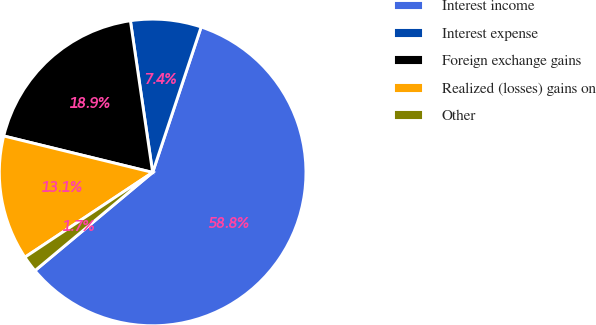Convert chart. <chart><loc_0><loc_0><loc_500><loc_500><pie_chart><fcel>Interest income<fcel>Interest expense<fcel>Foreign exchange gains<fcel>Realized (losses) gains on<fcel>Other<nl><fcel>58.81%<fcel>7.44%<fcel>18.86%<fcel>13.15%<fcel>1.74%<nl></chart> 